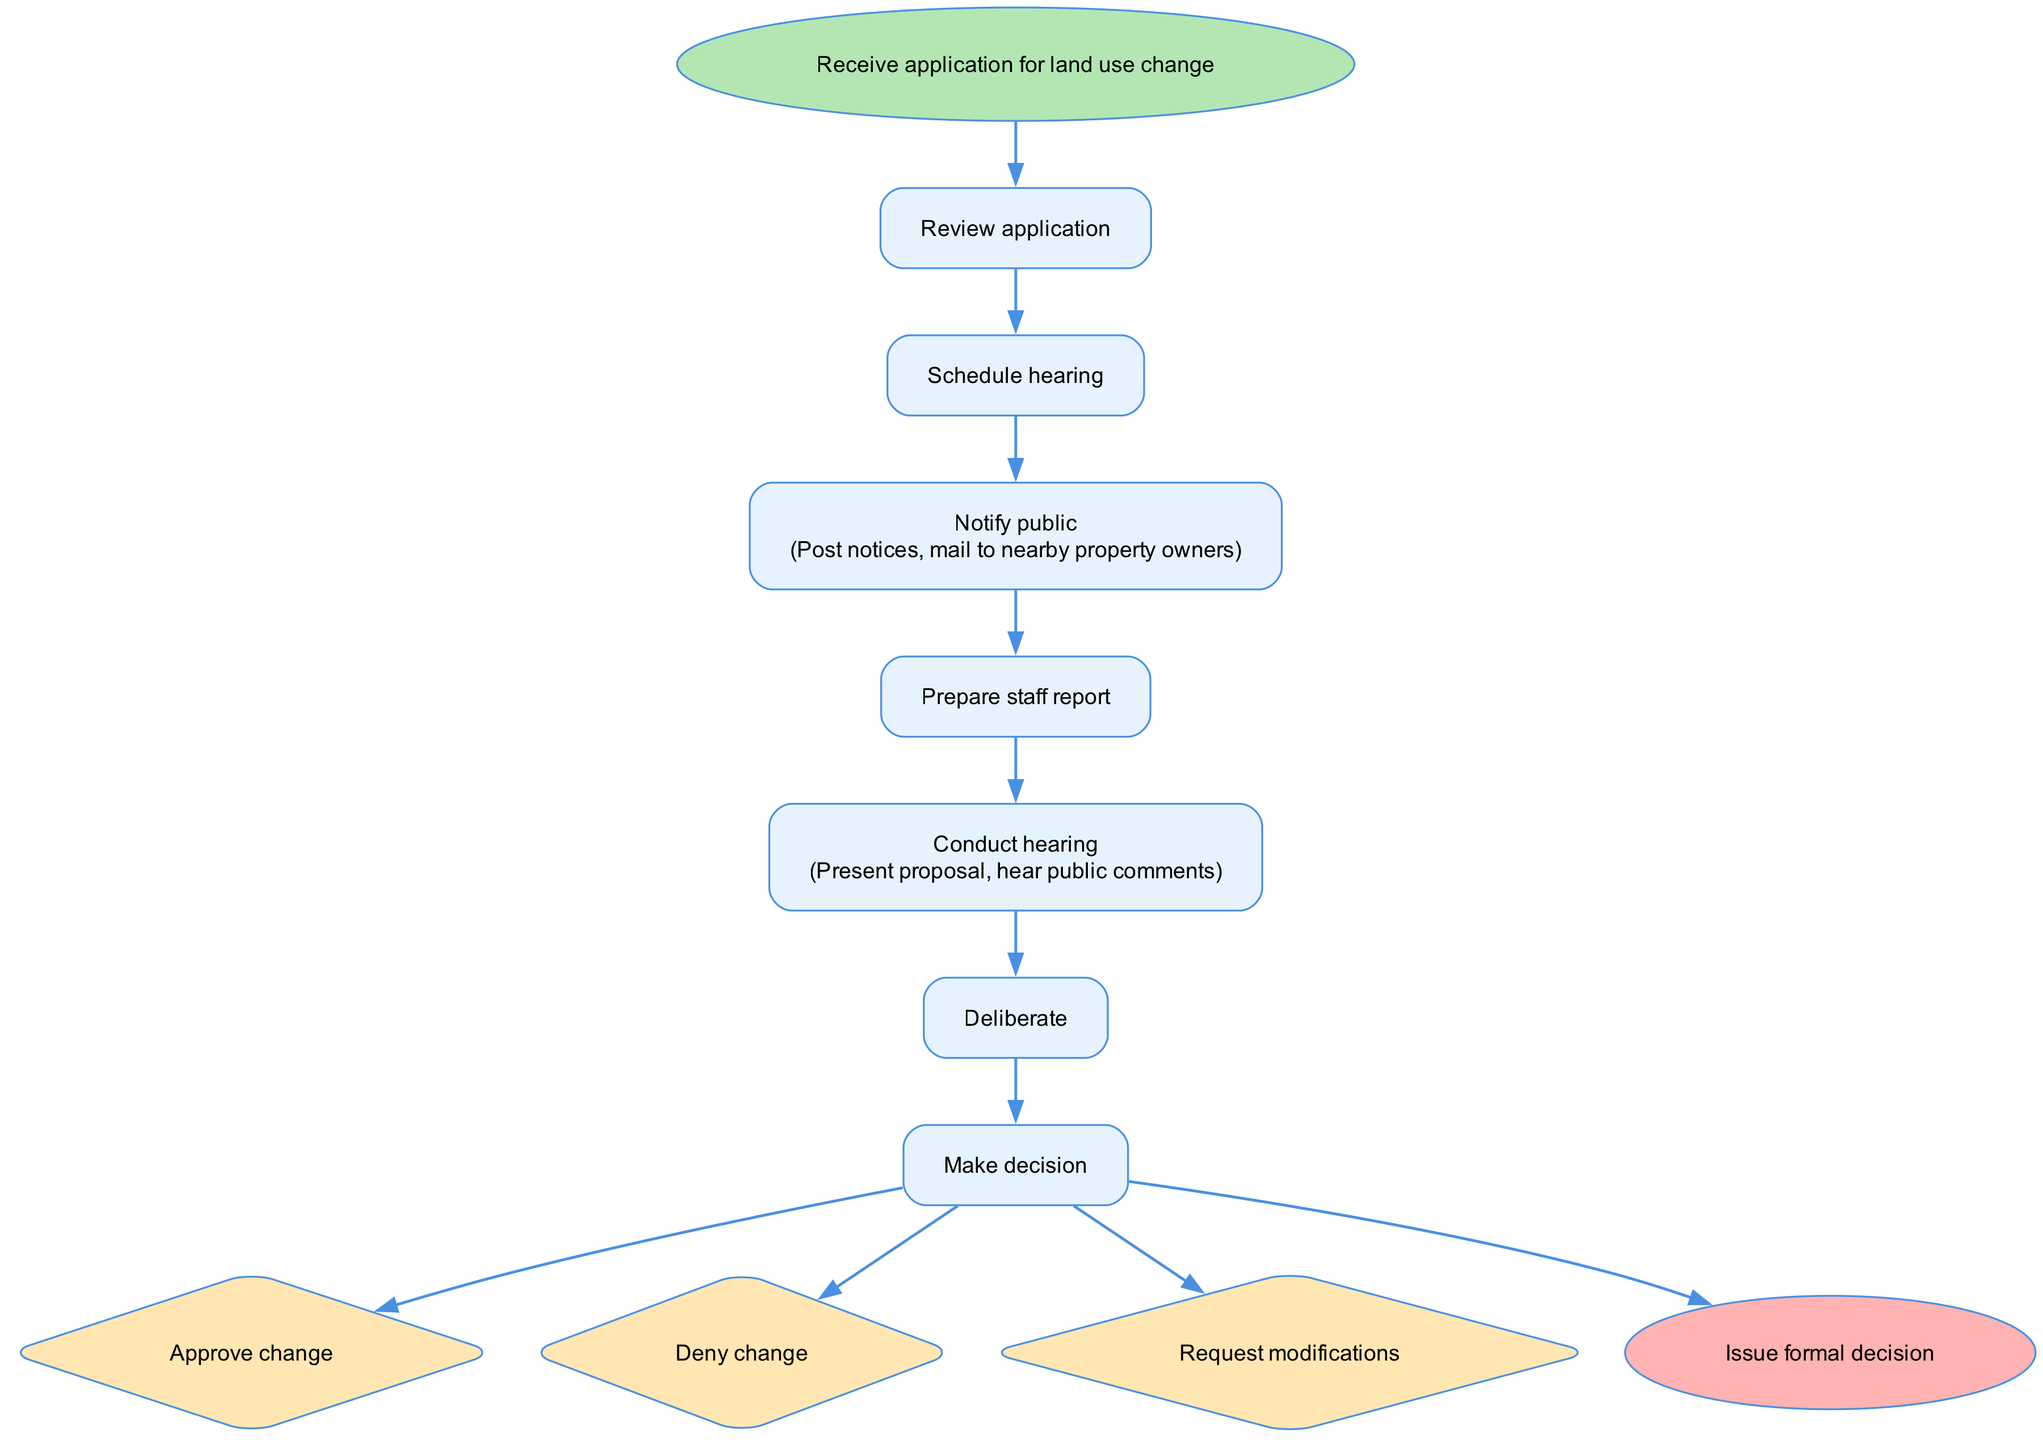what is the first step in the process? The first step in the flow chart is indicated as starting from the "Receive application for land use change". This is the entry point into the entire process.
Answer: Receive application for land use change how many steps are there in total? The diagram lists a sequence of steps including the start and end, with a total of seven distinct steps that progress through the process.
Answer: 7 what follows after reviewing the application? According to the flow chart, after the "Review application" step, the next action to take is to "Schedule hearing". This is a direct progression from one step to the next in the process.
Answer: Schedule hearing what is included in the public notification step? The "Notify public" step includes a description stating that notices need to be posted and mailed to nearby property owners. This additional detail is provided in parentheses for clarity.
Answer: Post notices, mail to nearby property owners what are the possible outcomes after making a decision? After the "Make decision" step concludes, there are three possible outcomes listed: "Approve change", "Deny change", and "Request modifications". These options represent the different directions the process can take based on the decision made.
Answer: Approve change, Deny change, Request modifications which step comes before conducting the hearing? The sequence shows that "Prepare staff report" precedes "Conduct hearing". It indicates that the staff report must be prepared before the hearing takes place.
Answer: Prepare staff report how does the process end? The flow chart indicates that the process concludes with the "Issue formal decision". This final step signifies the end of the hearing process and the formalization of the decision made.
Answer: Issue formal decision 